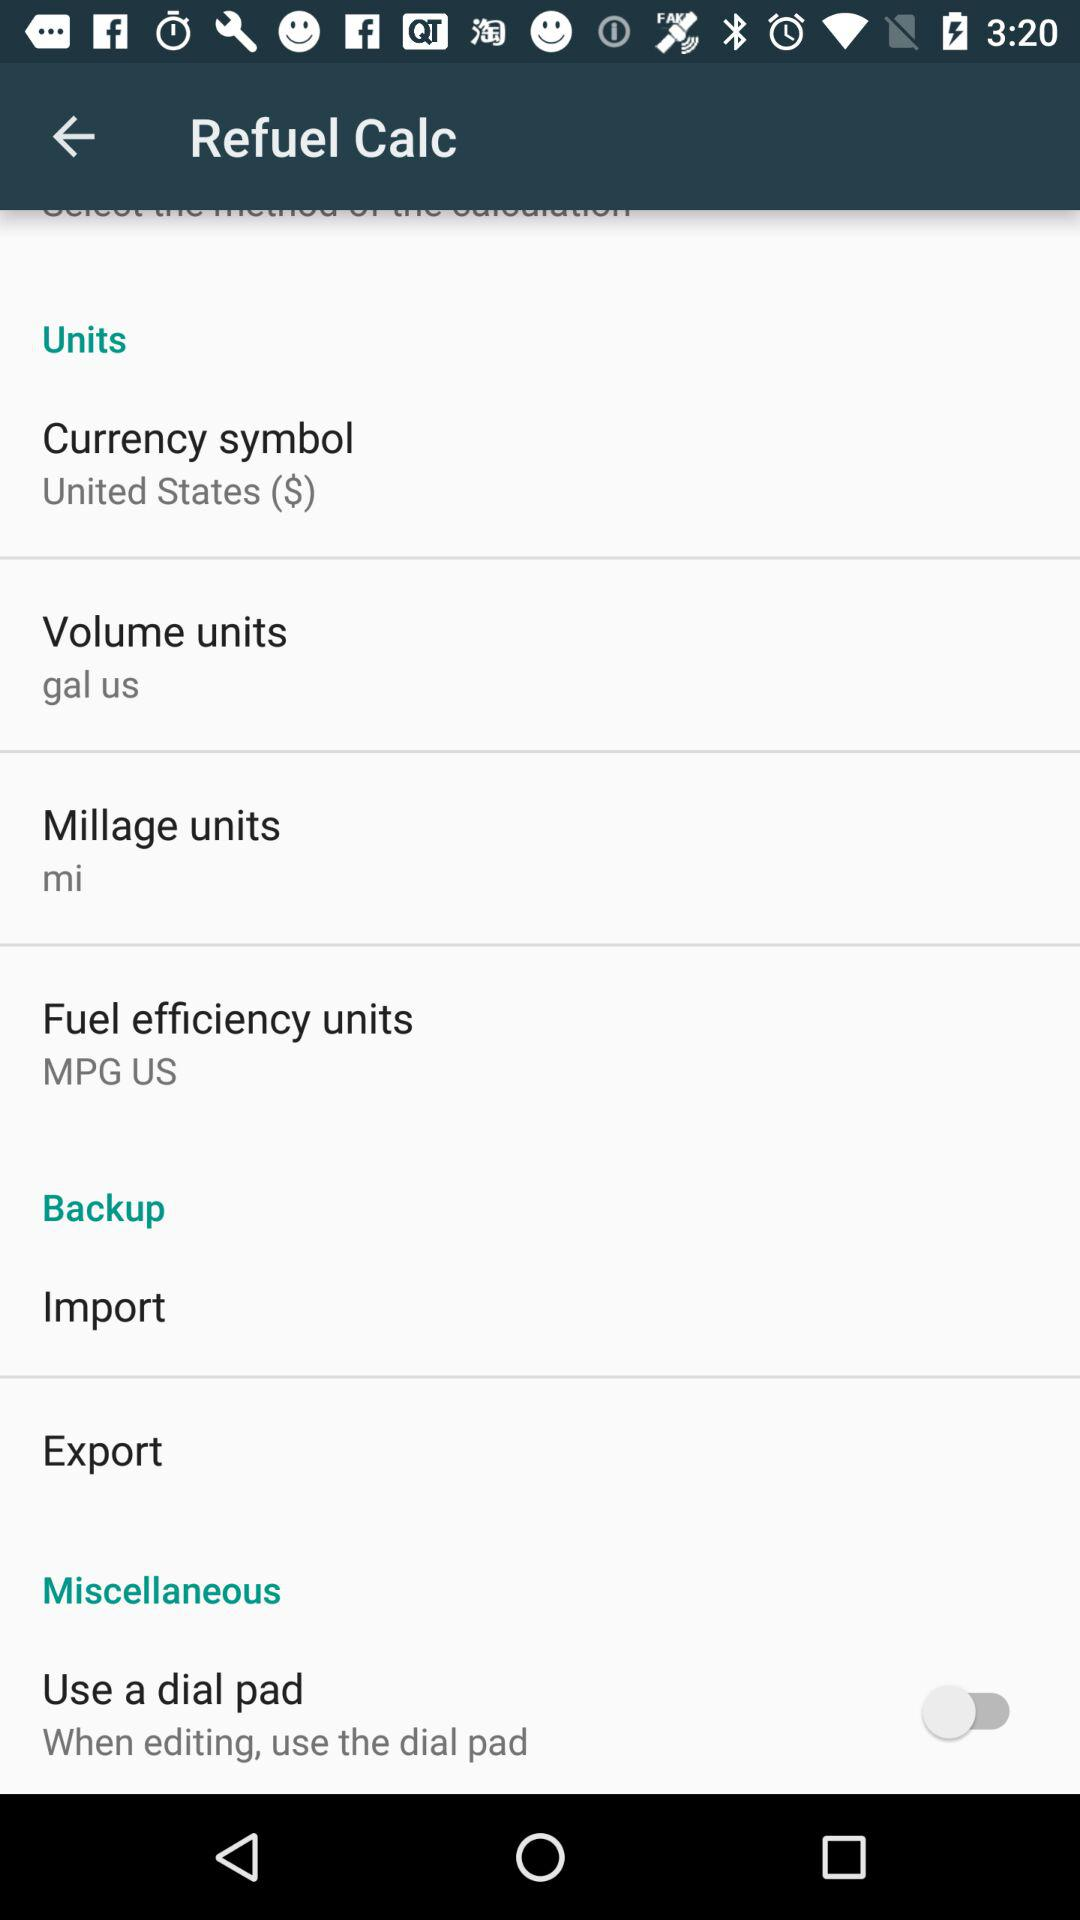What's the millage unit? The millage unit is miles. 